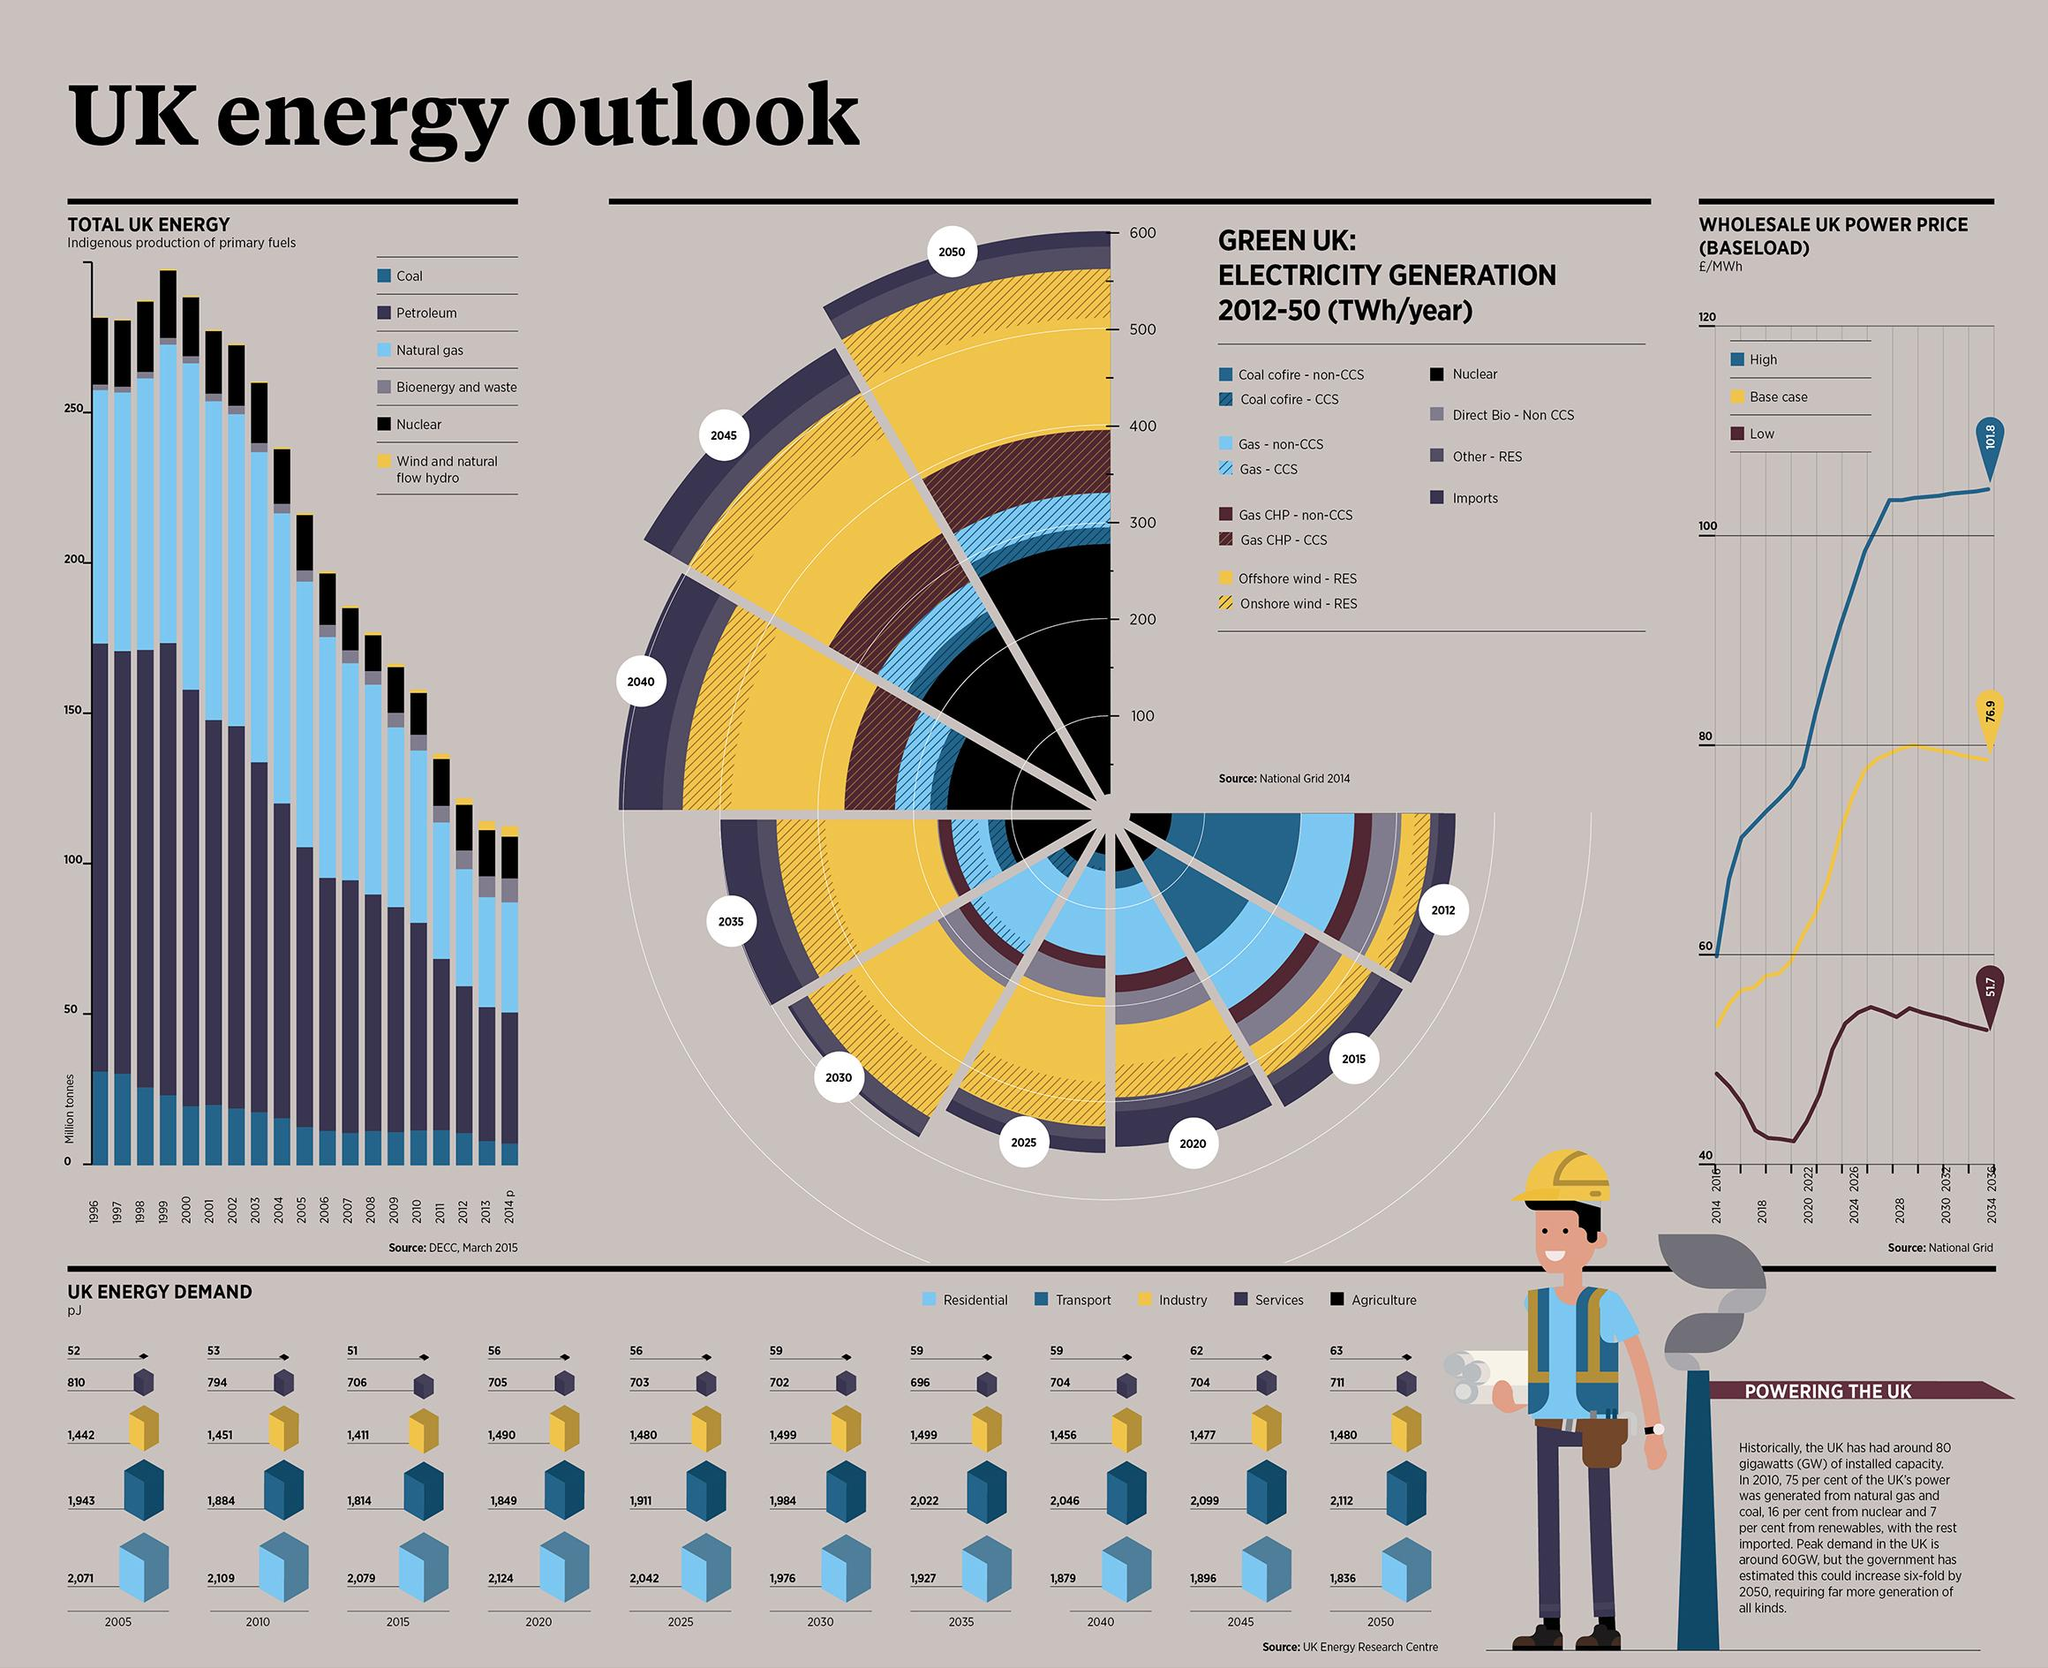Draw attention to some important aspects in this diagram. The energy demand in the UK's agricultural sector in 2015 was approximately 51 petajoules (PJ). In 2010, the residential sector in the UK had the highest rate of energy consumption. The estimated projected energy demand in the industrial sector of the UK by 2050 is expected to be approximately 1,480 petajoules. In 2005, the UK's energy demand in the service sector was approximately 810 petajoules (pJ). The estimated energy demand in the transport sector for the UK by 2040 is projected to be 2,046 petajoules. 